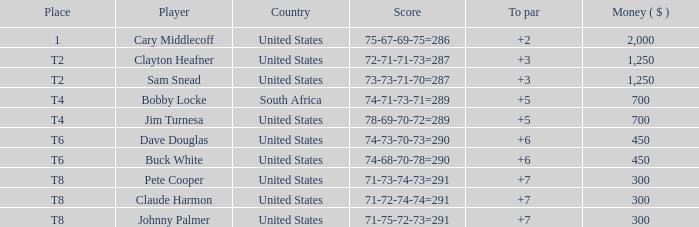I'm looking to parse the entire table for insights. Could you assist me with that? {'header': ['Place', 'Player', 'Country', 'Score', 'To par', 'Money ( $ )'], 'rows': [['1', 'Cary Middlecoff', 'United States', '75-67-69-75=286', '+2', '2,000'], ['T2', 'Clayton Heafner', 'United States', '72-71-71-73=287', '+3', '1,250'], ['T2', 'Sam Snead', 'United States', '73-73-71-70=287', '+3', '1,250'], ['T4', 'Bobby Locke', 'South Africa', '74-71-73-71=289', '+5', '700'], ['T4', 'Jim Turnesa', 'United States', '78-69-70-72=289', '+5', '700'], ['T6', 'Dave Douglas', 'United States', '74-73-70-73=290', '+6', '450'], ['T6', 'Buck White', 'United States', '74-68-70-78=290', '+6', '450'], ['T8', 'Pete Cooper', 'United States', '71-73-74-73=291', '+7', '300'], ['T8', 'Claude Harmon', 'United States', '71-72-74-74=291', '+7', '300'], ['T8', 'Johnny Palmer', 'United States', '71-75-72-73=291', '+7', '300']]} What Country is Player Sam Snead with a To par of less than 5 from? United States. 